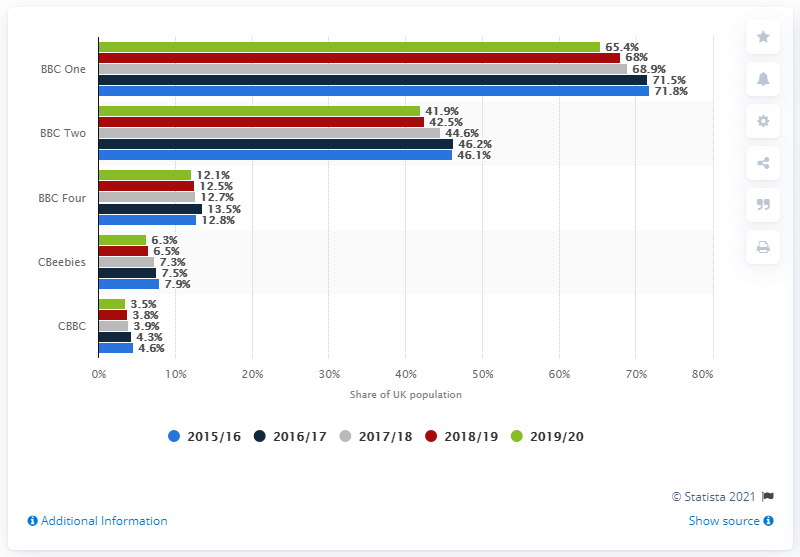Outline some significant characteristics in this image. In 2015/2016, BBC had its greatest weekly reach. In the 2019/2020 season, BBC One had the greatest weekly reach among all channels. 